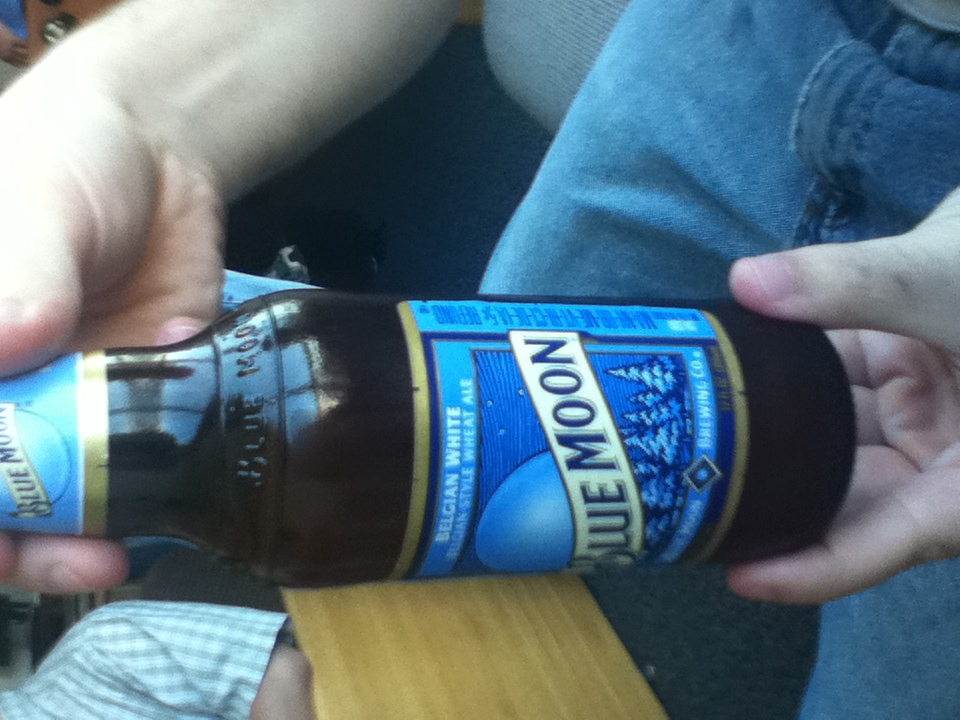How should this beer be served for the best tasting experience? Blue Moon beer should be served chilled in a tall, narrow glass which will help concentrate the carbonation and enhance the aromatic citrus notes. Adding a slice of orange as garnish isn't just traditional, it amplifies the beer’s flavor profile. 